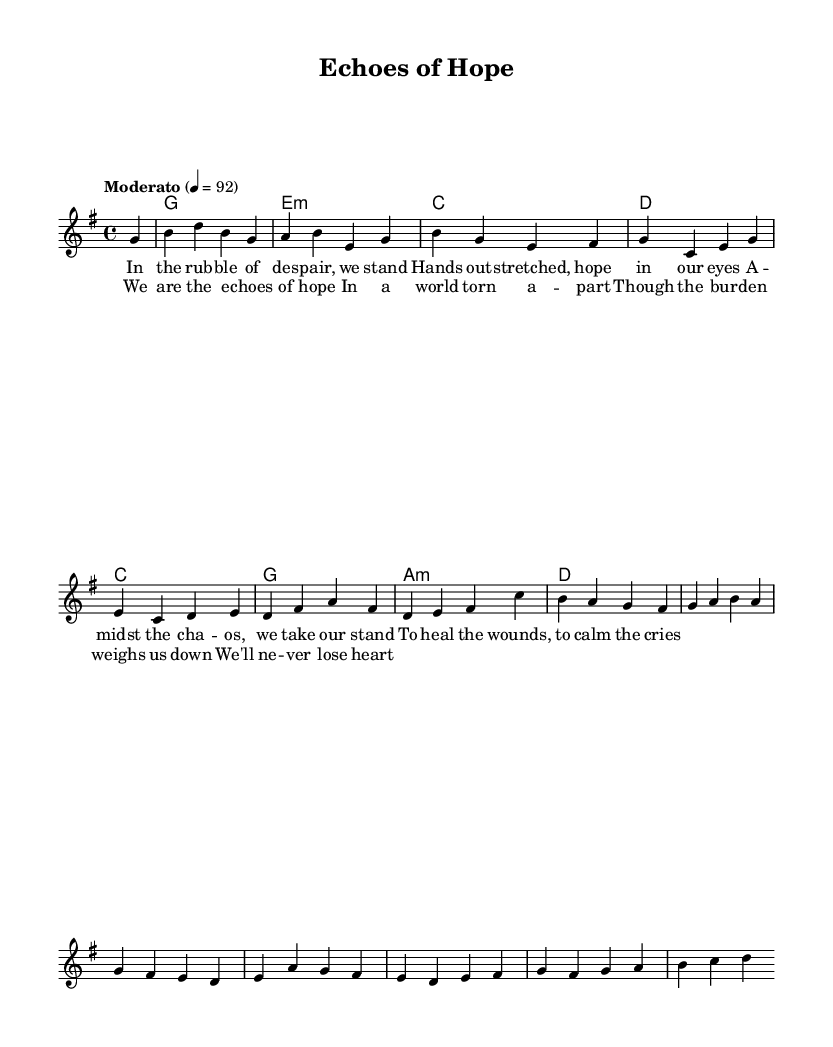What is the key signature of this music? The key signature is G major, which has one sharp (F#). This is indicated at the beginning of the score, showing that each F will be played as an F sharp.
Answer: G major What is the time signature of this piece? The time signature is 4/4, which means there are four beats per measure, and the quarter note receives one beat. This is typically found at the beginning of the music, right after the key signature.
Answer: 4/4 What is the tempo marking for this piece? The tempo marking is "Moderato," with a metronome marking of 92 beats per minute. This informs the performer about the intended speed of the music, which is indicated above the staff.
Answer: Moderato How many measures are in the melody section? The melody consists of 8 measures, which can be counted from the beginning to the end of the melody line. Each vertical line in the score represents a measure, and by counting them, we find there are eight.
Answer: 8 What is the first chord in the song? The first chord is G major, indicated in the harmonies section at the start of the score. This chord establishes the tonal center of the piece.
Answer: G major What lyrical theme is present in the chorus? The theme in the chorus is about hope amidst adversity. The lyrics express resilience despite burdens, which aligns with the emotional context of disaster relief work.
Answer: Hope How does the chord progression relate to the emotional tone of the lyrics? The chord progression moves through several tonalities (G, E minor, C, D), which creates a sense of movement and emotional depth. This supports the lyrics’ themes of hope and resilience in challenging circumstances, enhancing the overall emotional impact.
Answer: Emotional depth 